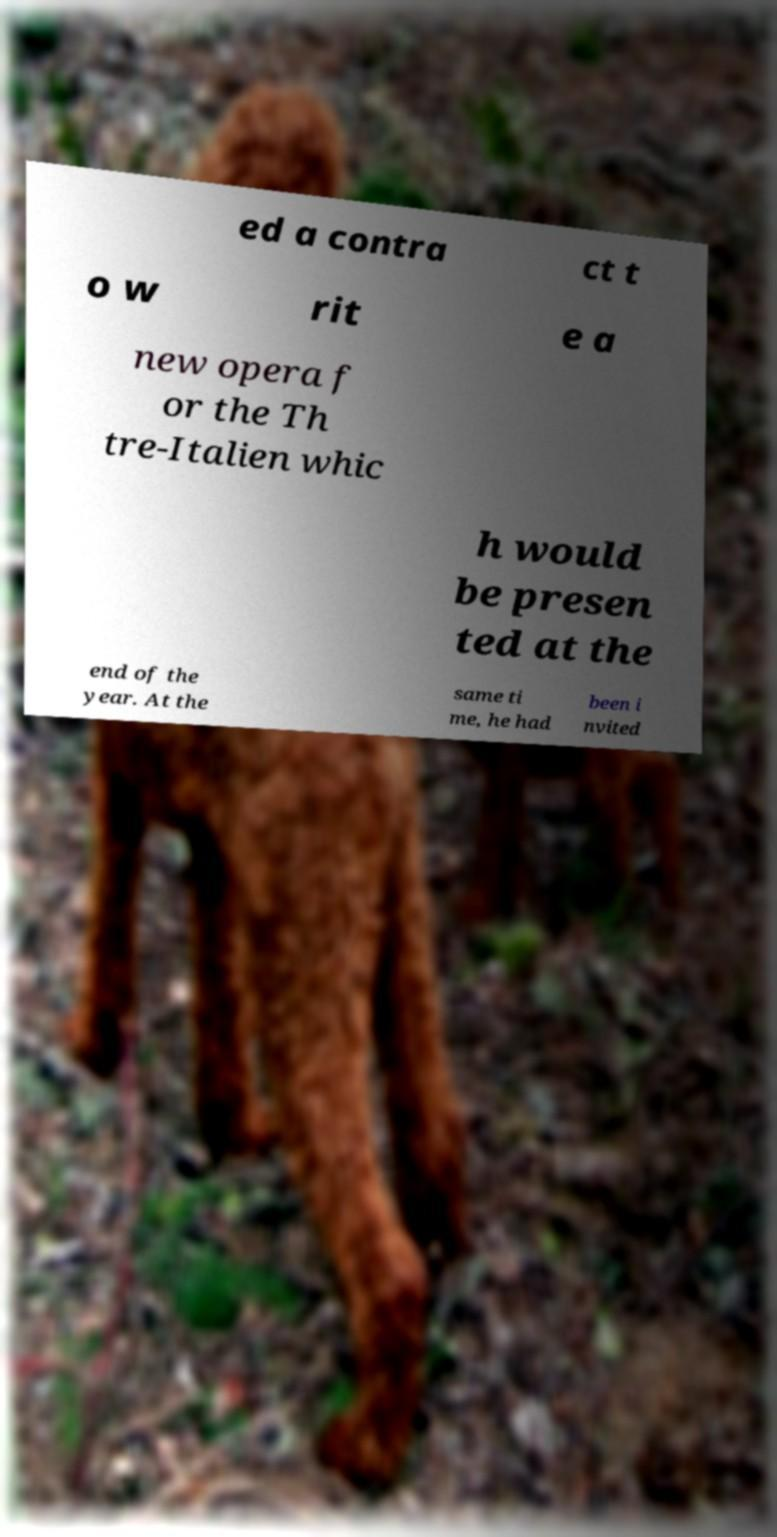Could you assist in decoding the text presented in this image and type it out clearly? ed a contra ct t o w rit e a new opera f or the Th tre-Italien whic h would be presen ted at the end of the year. At the same ti me, he had been i nvited 